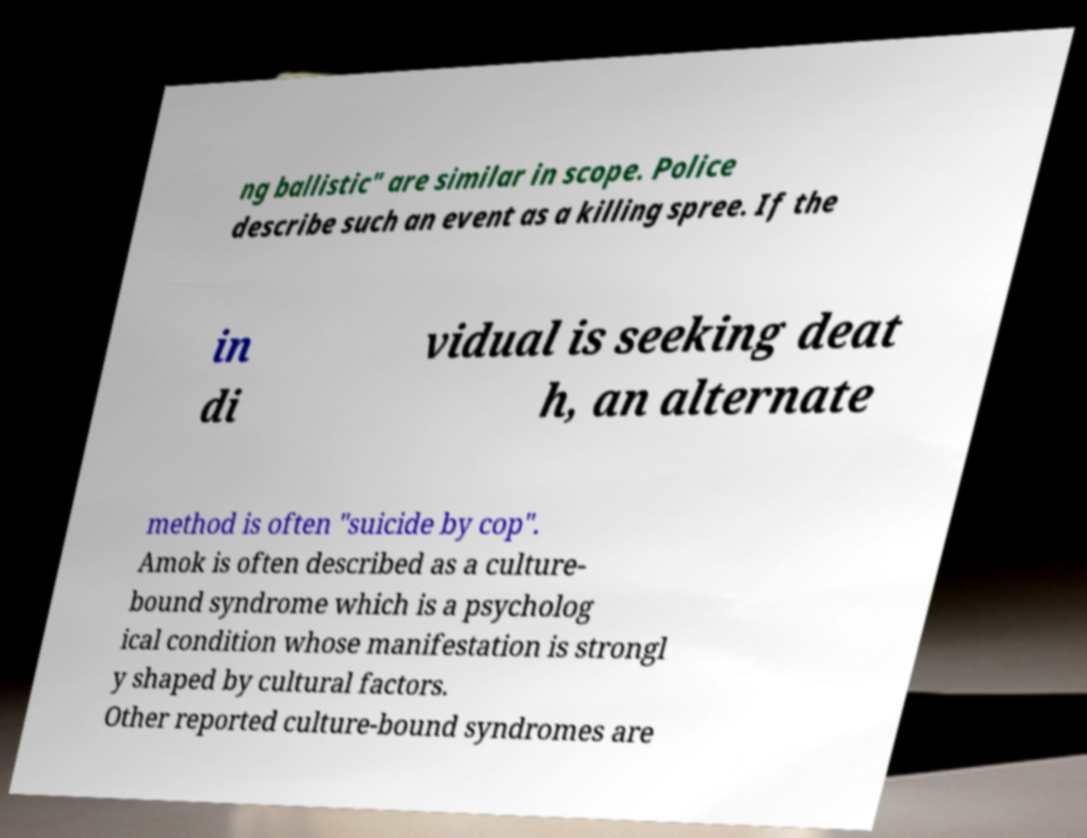Please identify and transcribe the text found in this image. ng ballistic" are similar in scope. Police describe such an event as a killing spree. If the in di vidual is seeking deat h, an alternate method is often "suicide by cop". Amok is often described as a culture- bound syndrome which is a psycholog ical condition whose manifestation is strongl y shaped by cultural factors. Other reported culture-bound syndromes are 